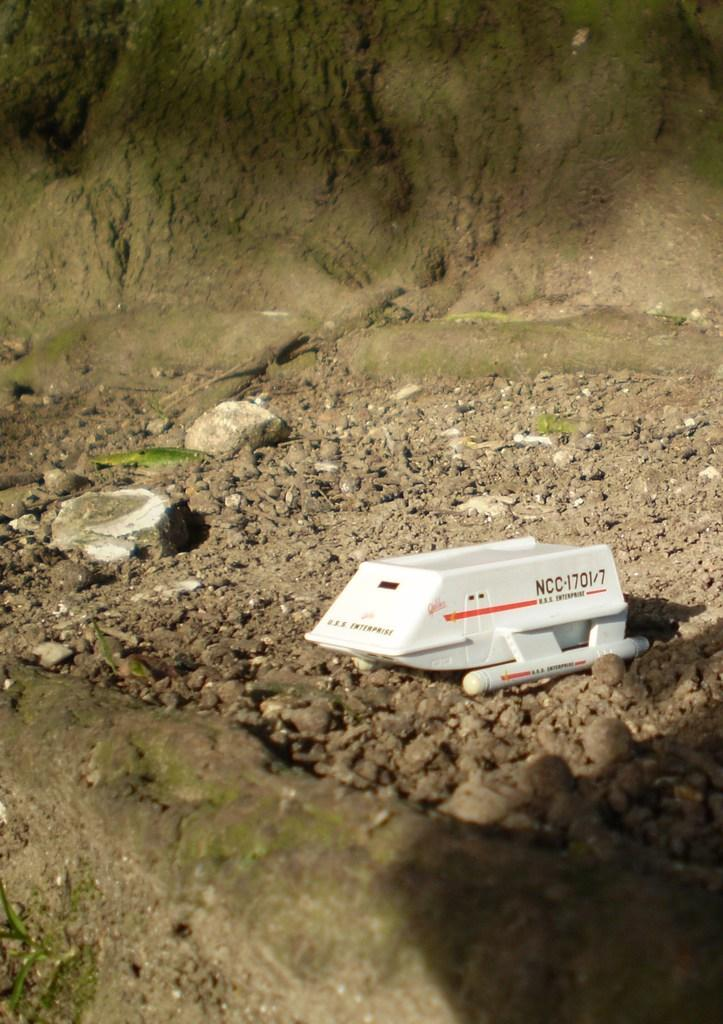What type of toy is placed on the stones in the image? There is a toy boat on the stones of a ground in the image. Can you describe the background of the image? There is a shadow on an object in the background. What impulse caused the toy boat to suddenly appear on the island in the image? There is no island present in the image, and the toy boat's presence is not attributed to any impulse. What type of magic is being used to create the shadow in the image? There is no indication of magic being used in the image; the shadow is a natural occurrence due to the presence of light and an object. 